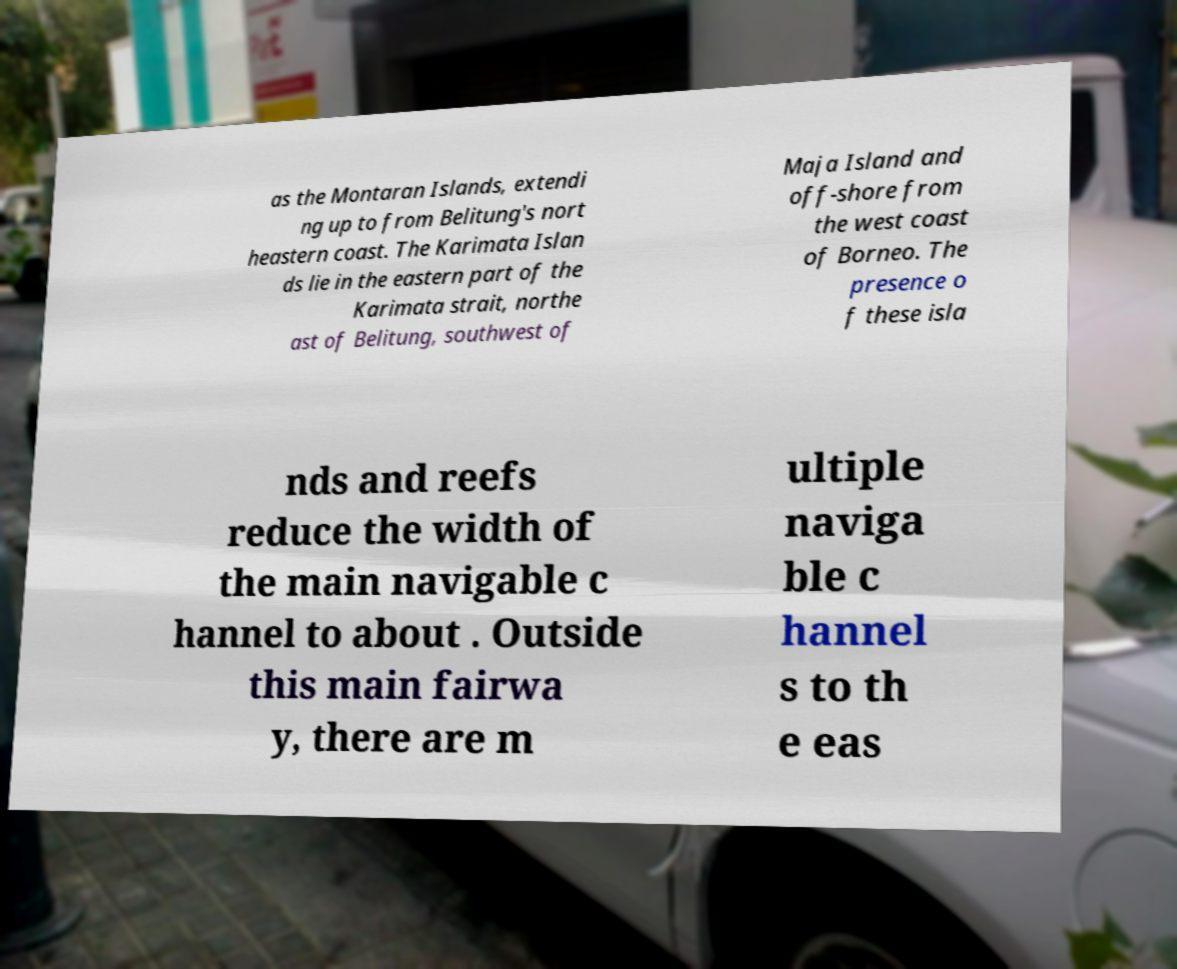Can you accurately transcribe the text from the provided image for me? as the Montaran Islands, extendi ng up to from Belitung's nort heastern coast. The Karimata Islan ds lie in the eastern part of the Karimata strait, northe ast of Belitung, southwest of Maja Island and off-shore from the west coast of Borneo. The presence o f these isla nds and reefs reduce the width of the main navigable c hannel to about . Outside this main fairwa y, there are m ultiple naviga ble c hannel s to th e eas 